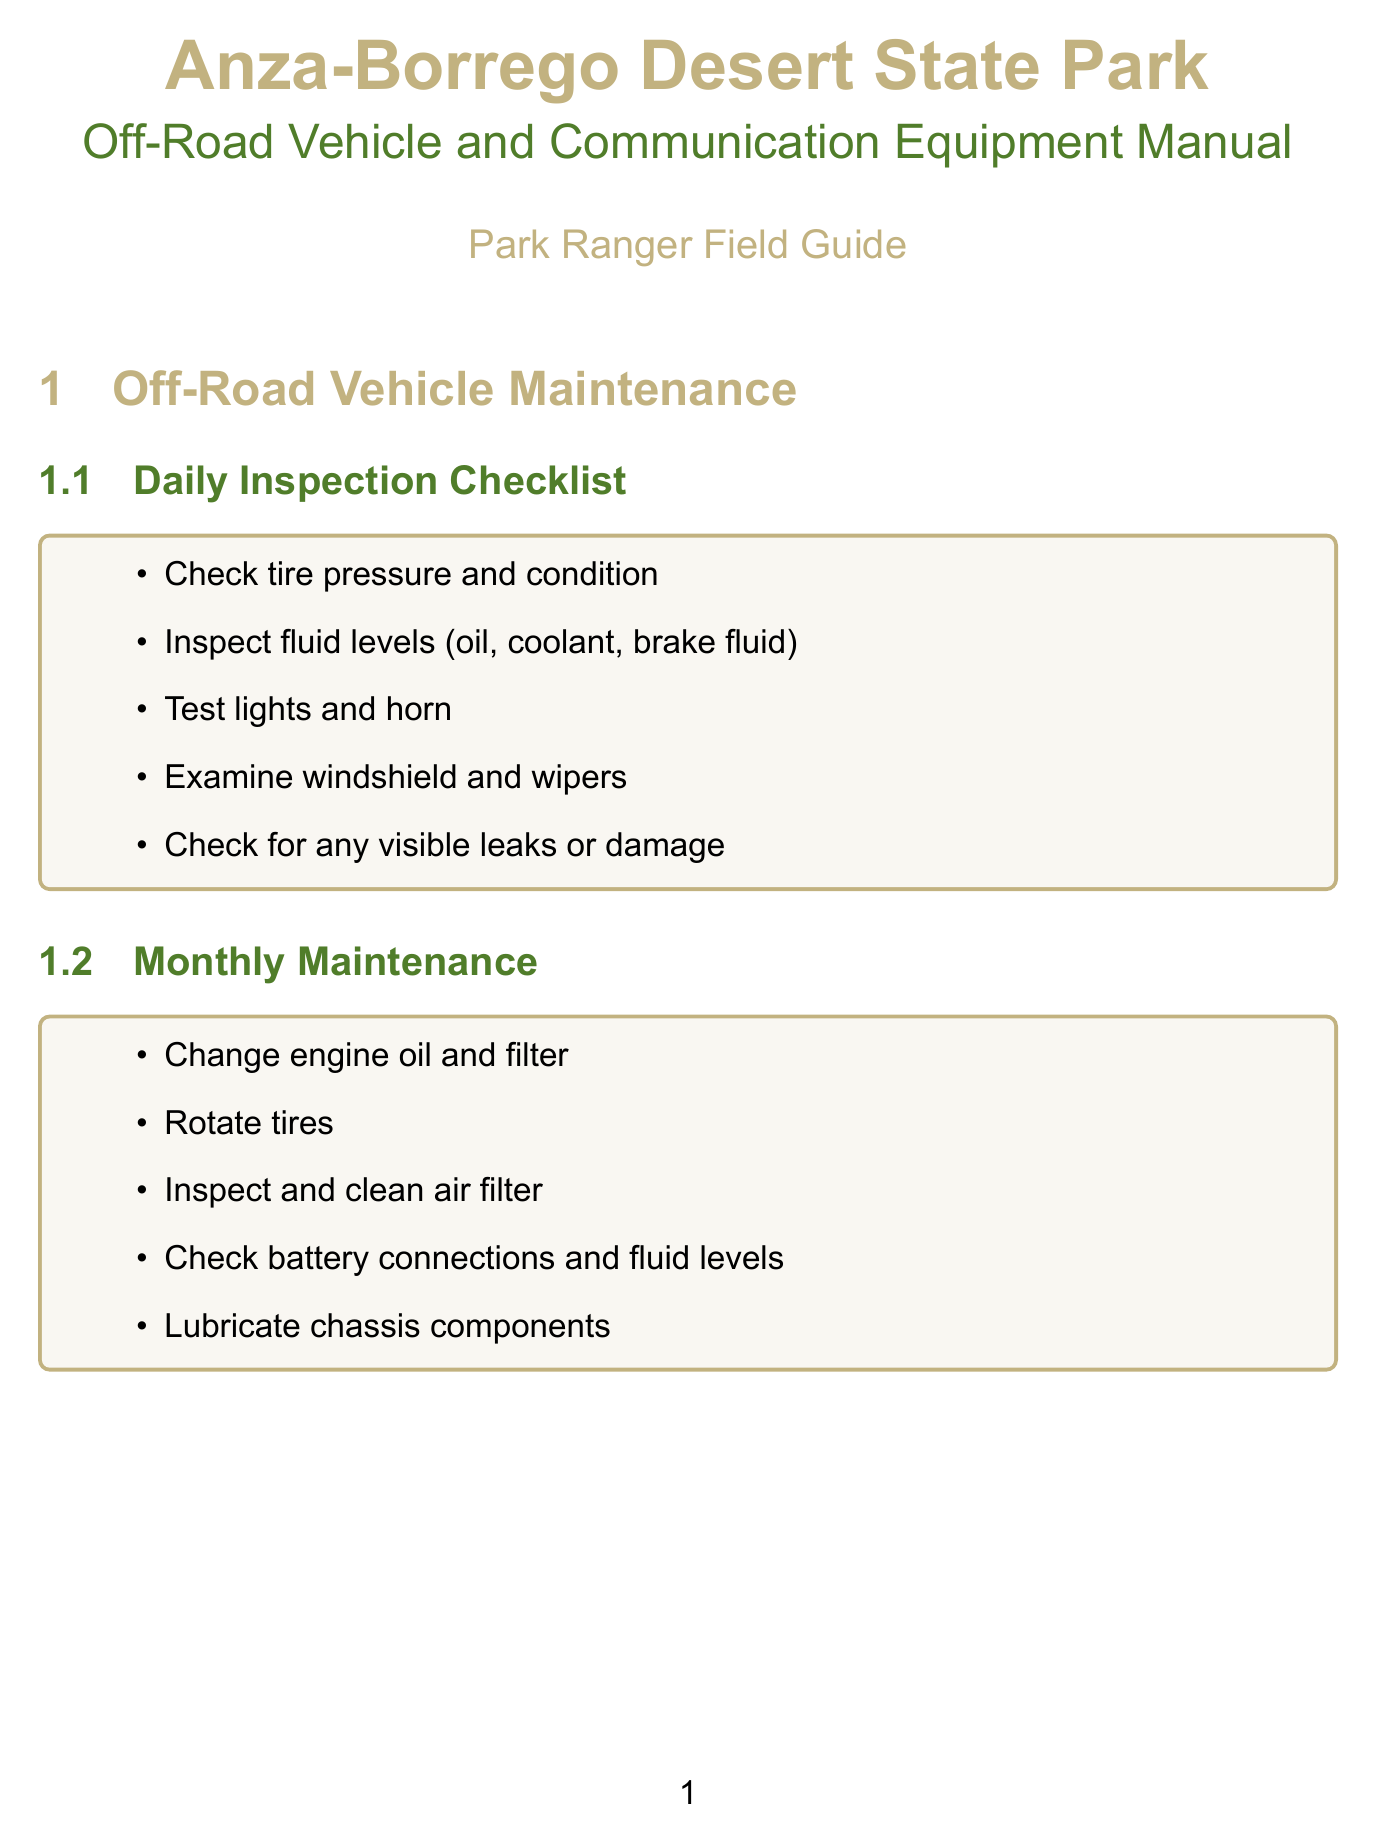What is included in the Daily Inspection Checklist? The Daily Inspection Checklist contains specific checks for the vehicle, such as tire pressure and fluid levels.
Answer: Check tire pressure and condition What should be done for Monthly Maintenance? Monthly Maintenance includes essential vehicle services that must be performed, including changing engine oil.
Answer: Change engine oil and filter What is a key aspect of Desert-Specific Maintenance? Desert-Specific Maintenance has particular tasks necessary due to the desert environment, such as cleaning the air intake.
Answer: Clean sand from air intake regularly Which vehicle's operation technique is advised for loose sand? The document specifies a strategy for driving on loose sand that involves maintaining a steady speed.
Answer: Maintain steady speed on loose sand What type of communication equipment is recommended for short-range communication? The manual suggests a specific model of radio for effective communication while operating in the park.
Answer: Motorola XPR 7550e What should you do in the event of a vehicle breakdown? The document outlines procedures to follow if a vehicle breaks down, focusing on repairs and assistance.
Answer: Attempt basic repairs using on-board toolkit How should electronics be protected in the desert? The manual provides guidance on care for electronic devices in harsh environments.
Answer: Use dust-proof cases for all electronic devices What is a storage recommendation for vehicles in the desert? The document advises precautions to take when storing vehicles to prevent damage from sun exposure.
Answer: Park in covered areas when possible to protect from sun damage 